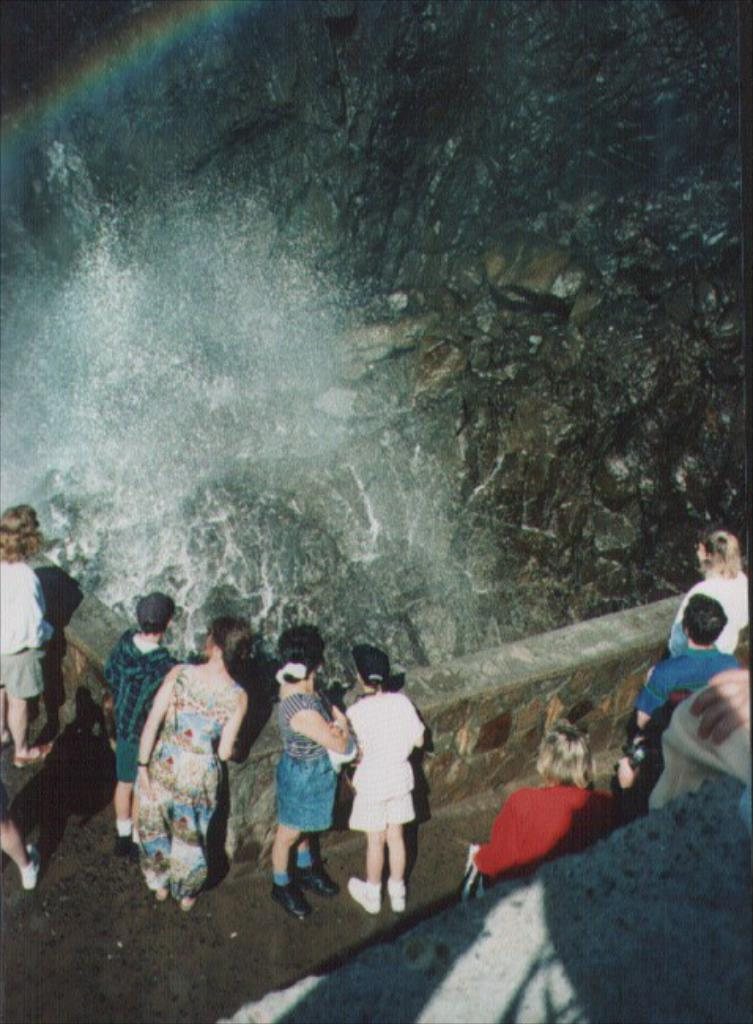What are the people in the image doing? The people in the image are standing near a wall. What natural feature can be seen in the image? There is a waterfall in the image. What type of geological formation is present in the image? There are rocks in the image. What type of brake can be seen on the father's bicycle in the image? There is no father or bicycle present in the image, so there is no brake to be seen. 